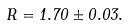<formula> <loc_0><loc_0><loc_500><loc_500>R = 1 . 7 0 \pm 0 . 0 3 .</formula> 